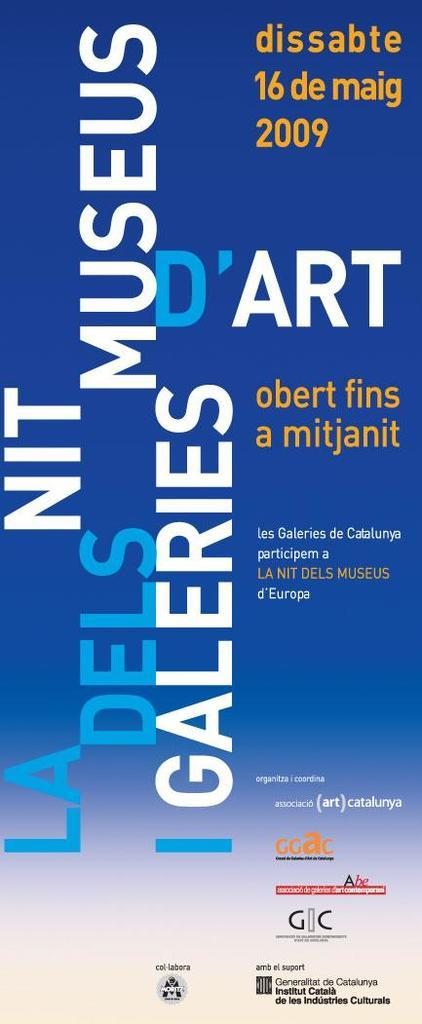<image>
Relay a brief, clear account of the picture shown. a blue and white pamphlet with galeries written on it 